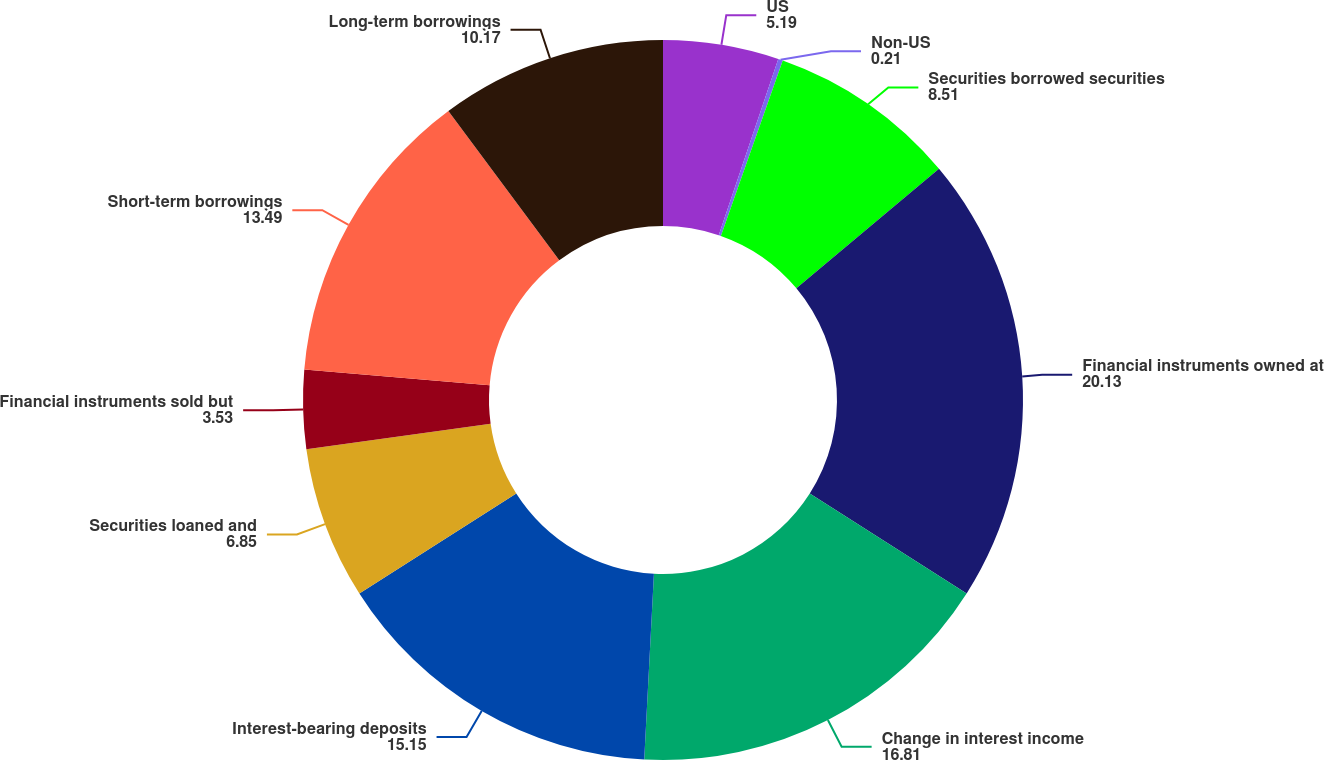Convert chart. <chart><loc_0><loc_0><loc_500><loc_500><pie_chart><fcel>US<fcel>Non-US<fcel>Securities borrowed securities<fcel>Financial instruments owned at<fcel>Change in interest income<fcel>Interest-bearing deposits<fcel>Securities loaned and<fcel>Financial instruments sold but<fcel>Short-term borrowings<fcel>Long-term borrowings<nl><fcel>5.19%<fcel>0.21%<fcel>8.51%<fcel>20.13%<fcel>16.81%<fcel>15.15%<fcel>6.85%<fcel>3.53%<fcel>13.49%<fcel>10.17%<nl></chart> 